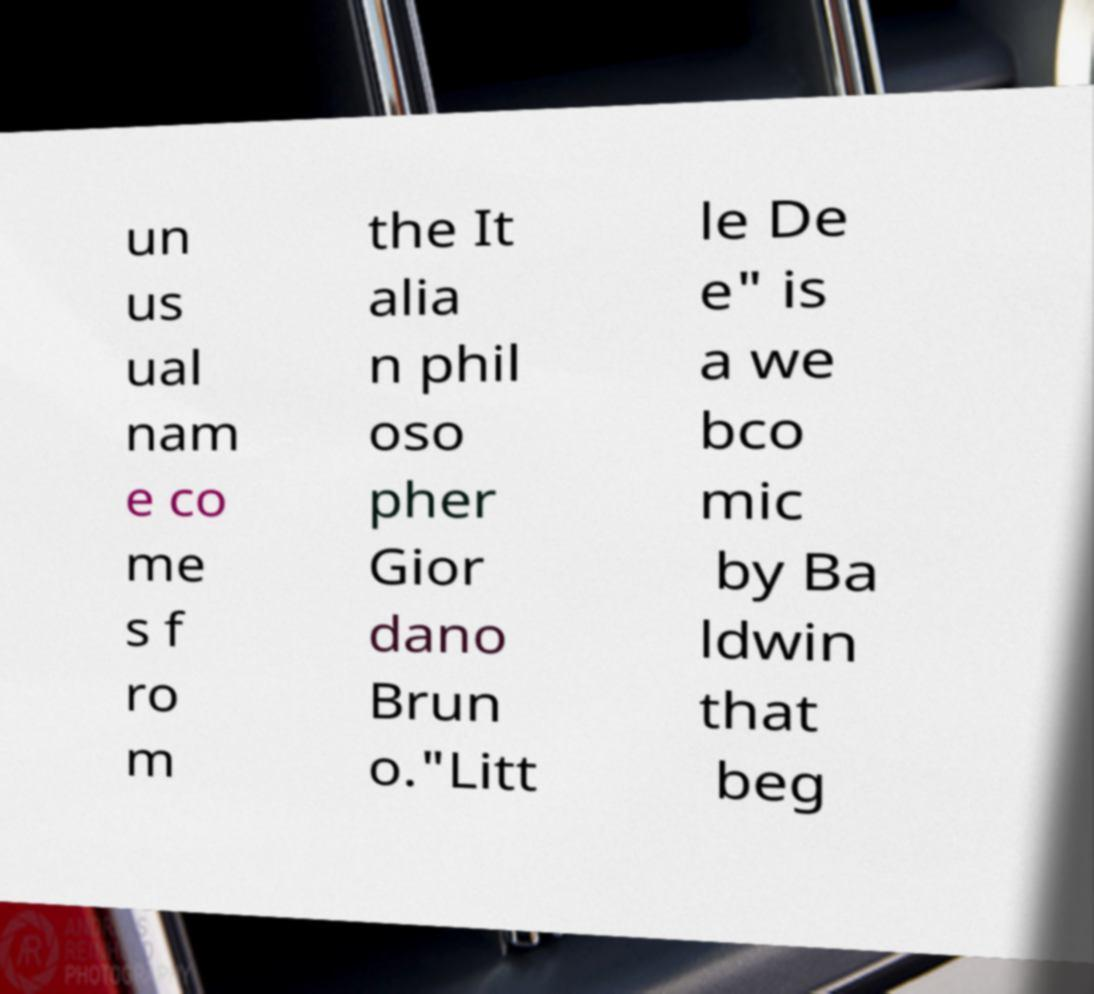Can you accurately transcribe the text from the provided image for me? un us ual nam e co me s f ro m the It alia n phil oso pher Gior dano Brun o."Litt le De e" is a we bco mic by Ba ldwin that beg 